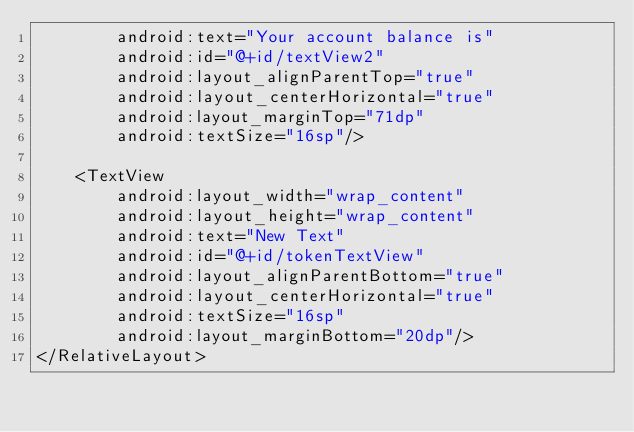Convert code to text. <code><loc_0><loc_0><loc_500><loc_500><_XML_>        android:text="Your account balance is"
        android:id="@+id/textView2"
        android:layout_alignParentTop="true"
        android:layout_centerHorizontal="true"
        android:layout_marginTop="71dp"
        android:textSize="16sp"/>

    <TextView
        android:layout_width="wrap_content"
        android:layout_height="wrap_content"
        android:text="New Text"
        android:id="@+id/tokenTextView"
        android:layout_alignParentBottom="true"
        android:layout_centerHorizontal="true"
        android:textSize="16sp"
        android:layout_marginBottom="20dp"/>
</RelativeLayout></code> 